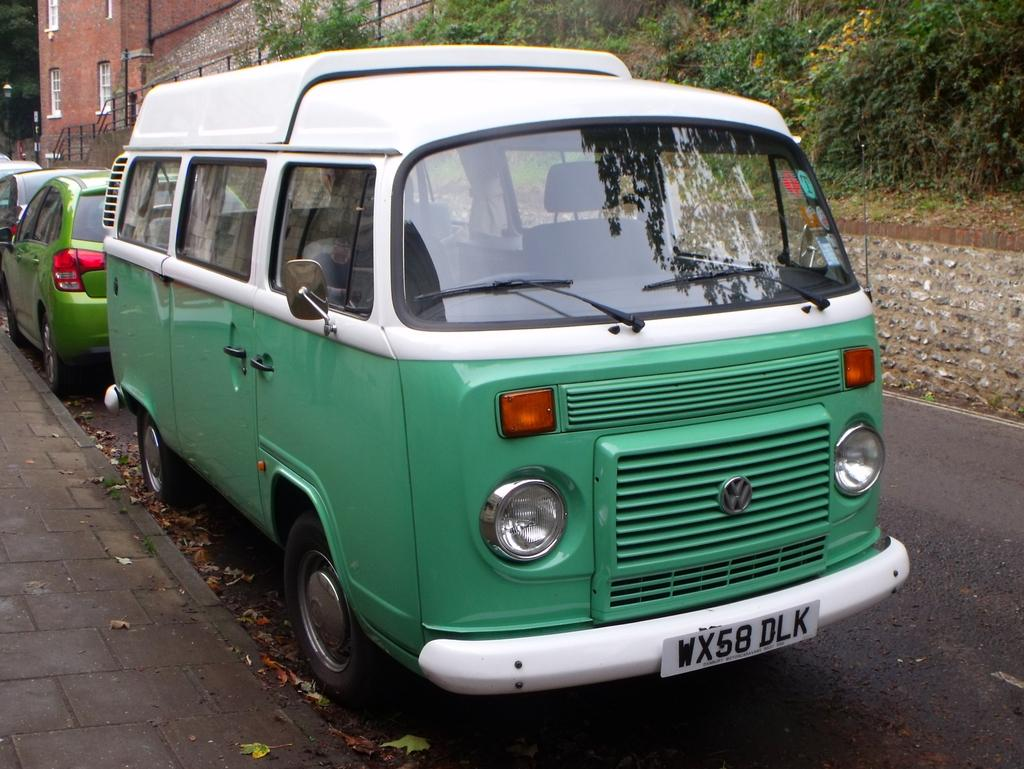What is the main feature of the image? There is a road in the image. What is happening on the road? There are vehicles on the road. What is located beside the road? There is a sidewalk in the image. What can be seen in the background of the image? There are trees and buildings in the background of the image. What is the color of the trees? The trees are green in color. What type of lettuce is being used to cover the cloth in the image? There is no lettuce or cloth present in the image. 